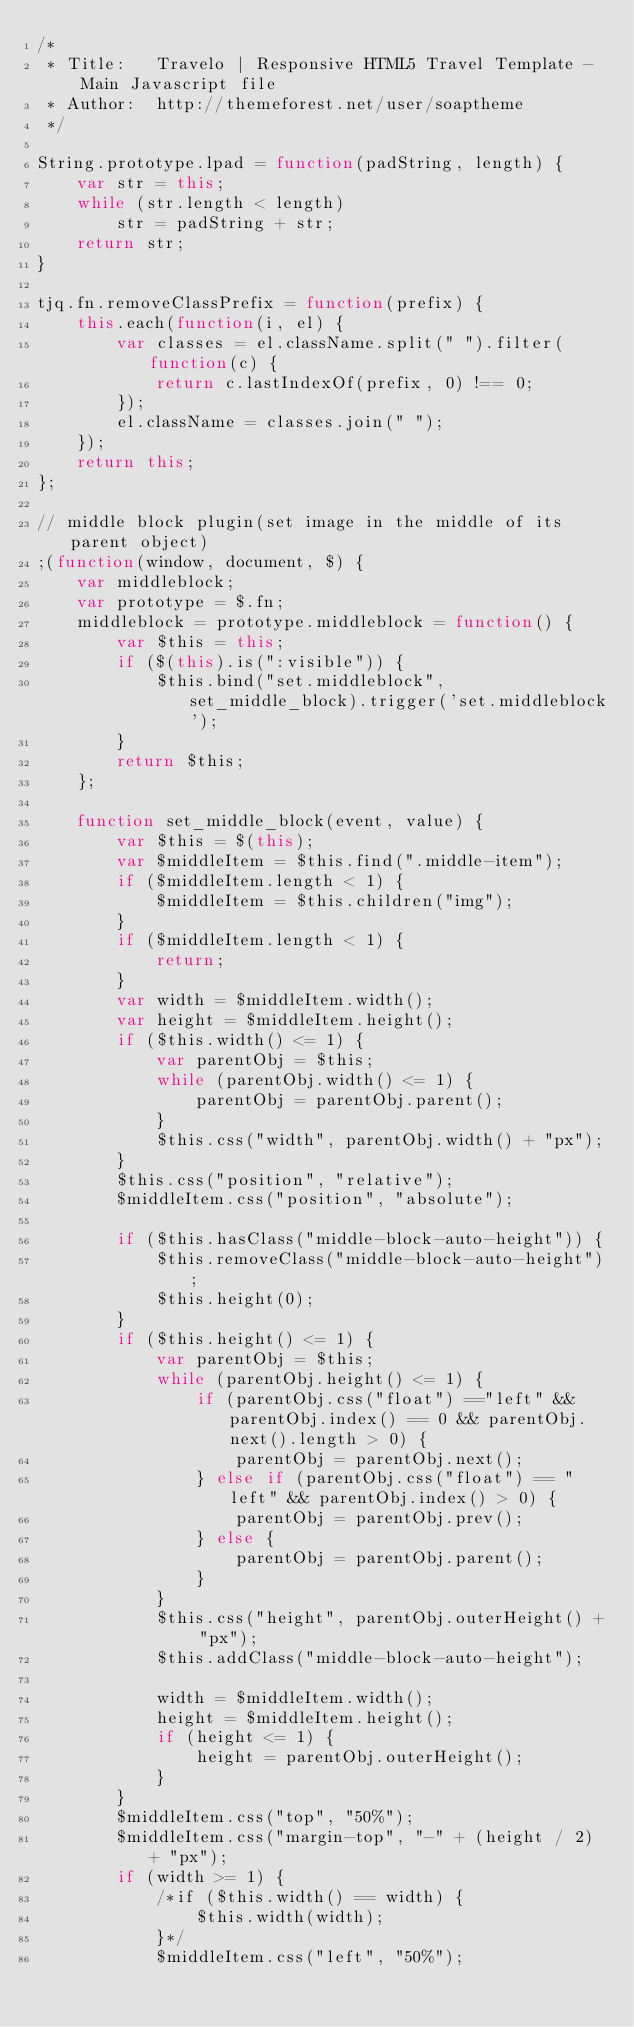<code> <loc_0><loc_0><loc_500><loc_500><_JavaScript_>/*
 * Title:   Travelo | Responsive HTML5 Travel Template - Main Javascript file
 * Author:  http://themeforest.net/user/soaptheme
 */

String.prototype.lpad = function(padString, length) {
    var str = this;
    while (str.length < length)
        str = padString + str;
    return str;
}

tjq.fn.removeClassPrefix = function(prefix) {
    this.each(function(i, el) {
        var classes = el.className.split(" ").filter(function(c) {
            return c.lastIndexOf(prefix, 0) !== 0;
        });
        el.className = classes.join(" ");
    });
    return this;
};

// middle block plugin(set image in the middle of its parent object)
;(function(window, document, $) {
    var middleblock;
    var prototype = $.fn;
    middleblock = prototype.middleblock = function() {
        var $this = this;
        if ($(this).is(":visible")) {
            $this.bind("set.middleblock", set_middle_block).trigger('set.middleblock');
        }
        return $this;
    };

    function set_middle_block(event, value) {
        var $this = $(this);
        var $middleItem = $this.find(".middle-item");
        if ($middleItem.length < 1) {
            $middleItem = $this.children("img");
        }
        if ($middleItem.length < 1) {
            return;
        }
        var width = $middleItem.width();
        var height = $middleItem.height();
        if ($this.width() <= 1) {
            var parentObj = $this;
            while (parentObj.width() <= 1) {
                parentObj = parentObj.parent();
            }
            $this.css("width", parentObj.width() + "px");
        }
        $this.css("position", "relative");
        $middleItem.css("position", "absolute");

        if ($this.hasClass("middle-block-auto-height")) {
            $this.removeClass("middle-block-auto-height");
            $this.height(0);
        }
        if ($this.height() <= 1) {
            var parentObj = $this;
            while (parentObj.height() <= 1) {
                if (parentObj.css("float") =="left" && parentObj.index() == 0 && parentObj.next().length > 0) {
                    parentObj = parentObj.next();
                } else if (parentObj.css("float") == "left" && parentObj.index() > 0) {
                    parentObj = parentObj.prev();
                } else {
                    parentObj = parentObj.parent();
                }
            }
            $this.css("height", parentObj.outerHeight() + "px");
            $this.addClass("middle-block-auto-height");

            width = $middleItem.width();
            height = $middleItem.height();
            if (height <= 1) {
                height = parentObj.outerHeight();
            }
        }
        $middleItem.css("top", "50%");
        $middleItem.css("margin-top", "-" + (height / 2) + "px");
        if (width >= 1) {
            /*if ($this.width() == width) {
                $this.width(width);
            }*/
            $middleItem.css("left", "50%");</code> 